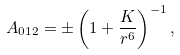Convert formula to latex. <formula><loc_0><loc_0><loc_500><loc_500>A _ { 0 1 2 } = \pm \left ( 1 + \frac { K } { r ^ { 6 } } \right ) ^ { - 1 } ,</formula> 